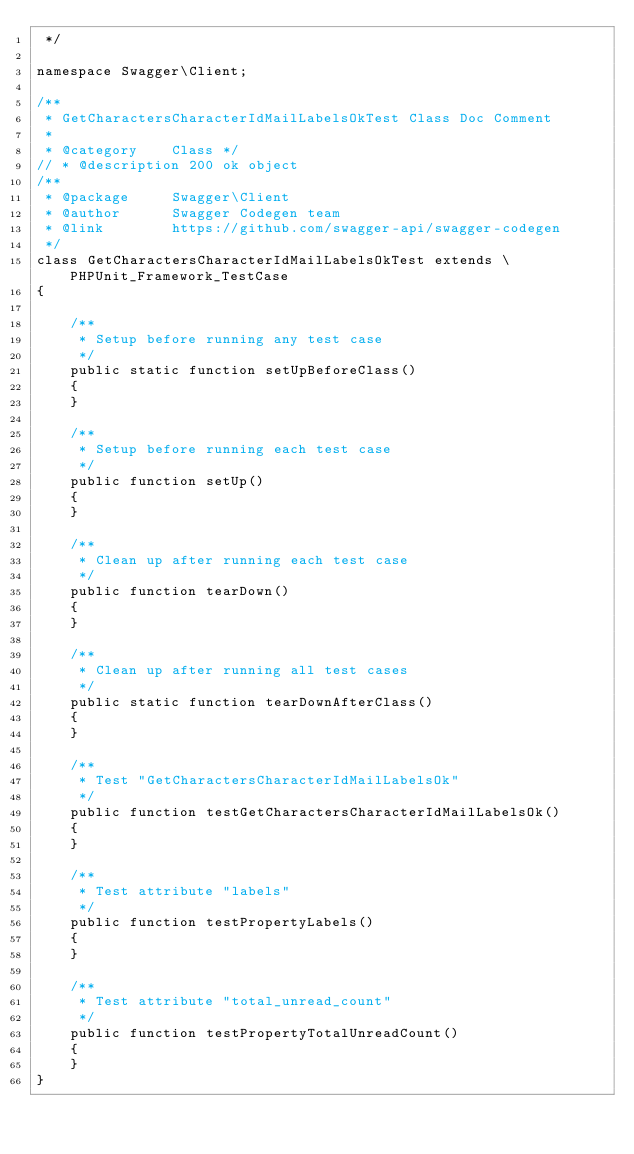<code> <loc_0><loc_0><loc_500><loc_500><_PHP_> */

namespace Swagger\Client;

/**
 * GetCharactersCharacterIdMailLabelsOkTest Class Doc Comment
 *
 * @category    Class */
// * @description 200 ok object
/**
 * @package     Swagger\Client
 * @author      Swagger Codegen team
 * @link        https://github.com/swagger-api/swagger-codegen
 */
class GetCharactersCharacterIdMailLabelsOkTest extends \PHPUnit_Framework_TestCase
{

    /**
     * Setup before running any test case
     */
    public static function setUpBeforeClass()
    {
    }

    /**
     * Setup before running each test case
     */
    public function setUp()
    {
    }

    /**
     * Clean up after running each test case
     */
    public function tearDown()
    {
    }

    /**
     * Clean up after running all test cases
     */
    public static function tearDownAfterClass()
    {
    }

    /**
     * Test "GetCharactersCharacterIdMailLabelsOk"
     */
    public function testGetCharactersCharacterIdMailLabelsOk()
    {
    }

    /**
     * Test attribute "labels"
     */
    public function testPropertyLabels()
    {
    }

    /**
     * Test attribute "total_unread_count"
     */
    public function testPropertyTotalUnreadCount()
    {
    }
}
</code> 